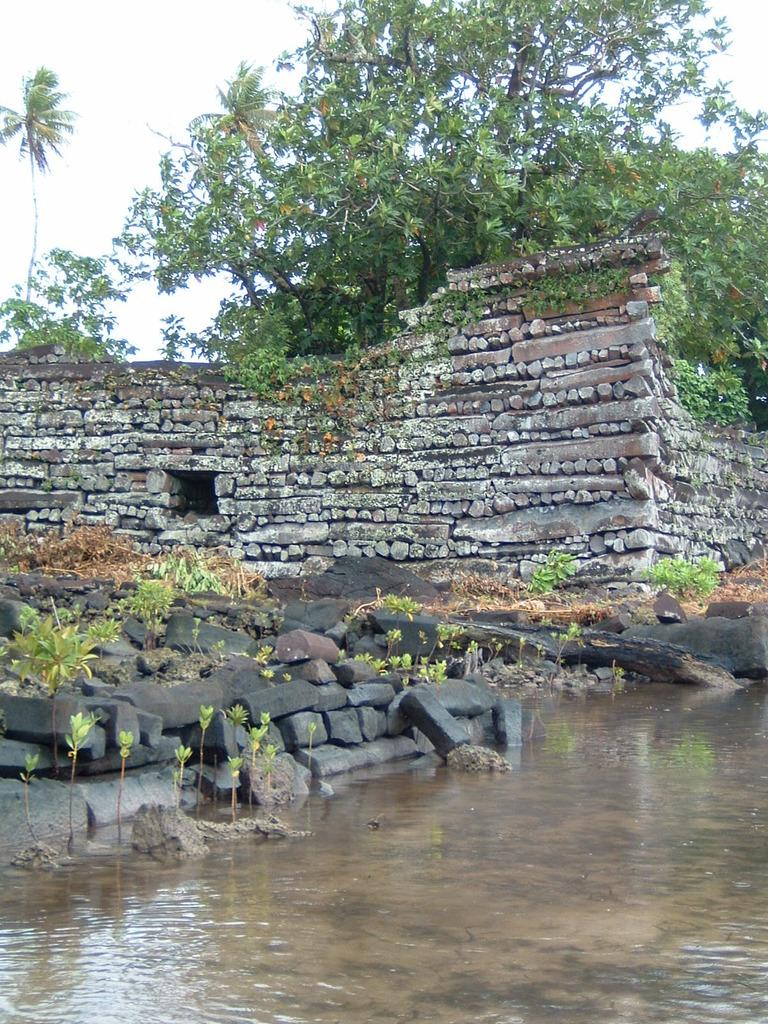What type of water body is present in the image? There is a pond in the image. What other natural elements can be seen in the image? There are plants, rocks, and trees in the image. What type of structure is visible in the background of the image? There is a stone structure in the background of the image. What is visible at the top of the image? The sky is visible at the top of the image. How many snails can be seen crawling on the stone structure in the image? There are no snails visible in the image; only the pond, plants, rocks, trees, stone structure, and sky are present. 